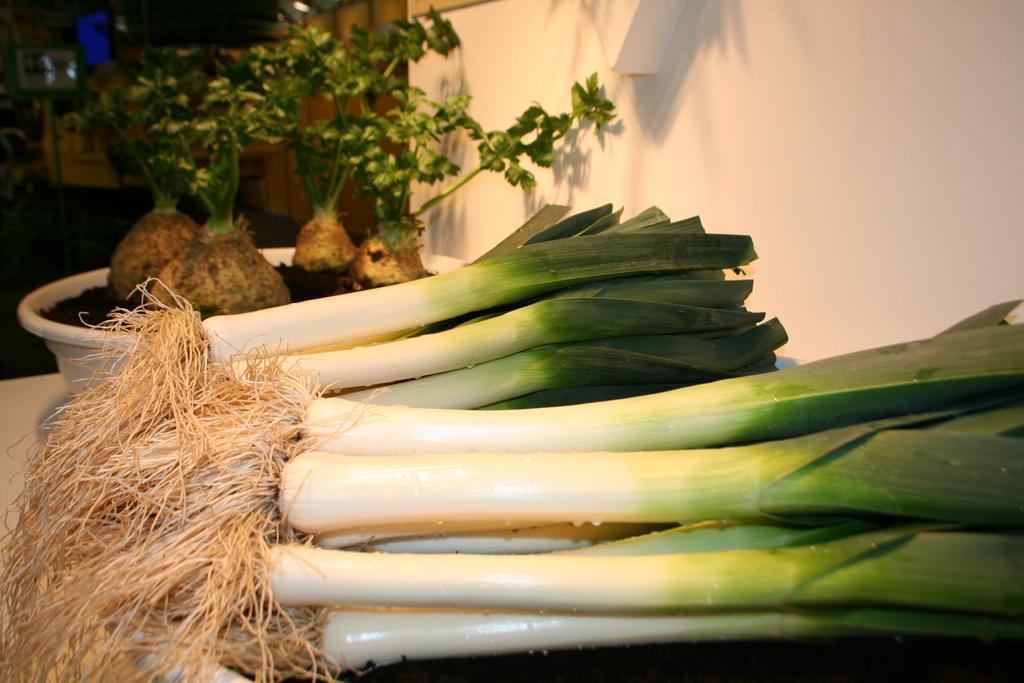Please provide a concise description of this image. In this picture I can see few weeks at the bottom, there are plants on the left side. On the right side there is a wall. 